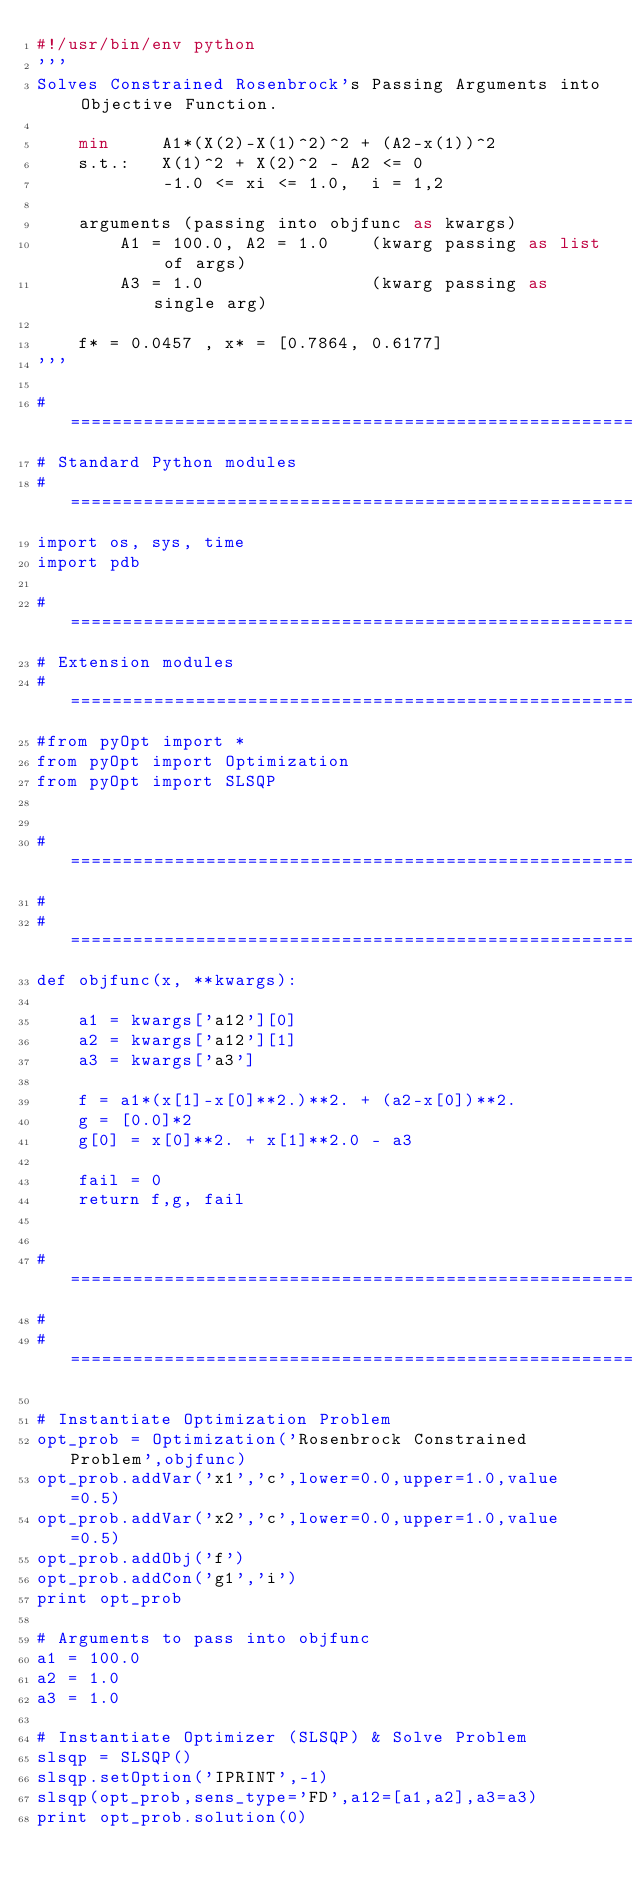<code> <loc_0><loc_0><loc_500><loc_500><_Python_>#!/usr/bin/env python
'''
Solves Constrained Rosenbrock's Passing Arguments into Objective Function.

    min 	A1*(X(2)-X(1)^2)^2 + (A2-x(1))^2
    s.t.:	X(1)^2 + X(2)^2 - A2 <= 0
            -1.0 <= xi <= 1.0,  i = 1,2
            
    arguments (passing into objfunc as kwargs)
        A1 = 100.0, A2 = 1.0    (kwarg passing as list of args)
        A3 = 1.0                (kwarg passing as single arg)
    
    f* = 0.0457 , x* = [0.7864, 0.6177]
'''

# =============================================================================
# Standard Python modules
# =============================================================================
import os, sys, time
import pdb

# =============================================================================
# Extension modules
# =============================================================================
#from pyOpt import *
from pyOpt import Optimization
from pyOpt import SLSQP


# =============================================================================
# 
# =============================================================================
def objfunc(x, **kwargs):
    
    a1 = kwargs['a12'][0]
    a2 = kwargs['a12'][1]
    a3 = kwargs['a3']
    
    f = a1*(x[1]-x[0]**2.)**2. + (a2-x[0])**2.
    g = [0.0]*2
    g[0] = x[0]**2. + x[1]**2.0 - a3
    
    fail = 0
    return f,g, fail
    

# =============================================================================
# 
# =============================================================================

# Instantiate Optimization Problem 
opt_prob = Optimization('Rosenbrock Constrained Problem',objfunc)
opt_prob.addVar('x1','c',lower=0.0,upper=1.0,value=0.5)
opt_prob.addVar('x2','c',lower=0.0,upper=1.0,value=0.5)
opt_prob.addObj('f')
opt_prob.addCon('g1','i')
print opt_prob

# Arguments to pass into objfunc
a1 = 100.0
a2 = 1.0
a3 = 1.0

# Instantiate Optimizer (SLSQP) & Solve Problem
slsqp = SLSQP()
slsqp.setOption('IPRINT',-1)
slsqp(opt_prob,sens_type='FD',a12=[a1,a2],a3=a3)
print opt_prob.solution(0)
</code> 